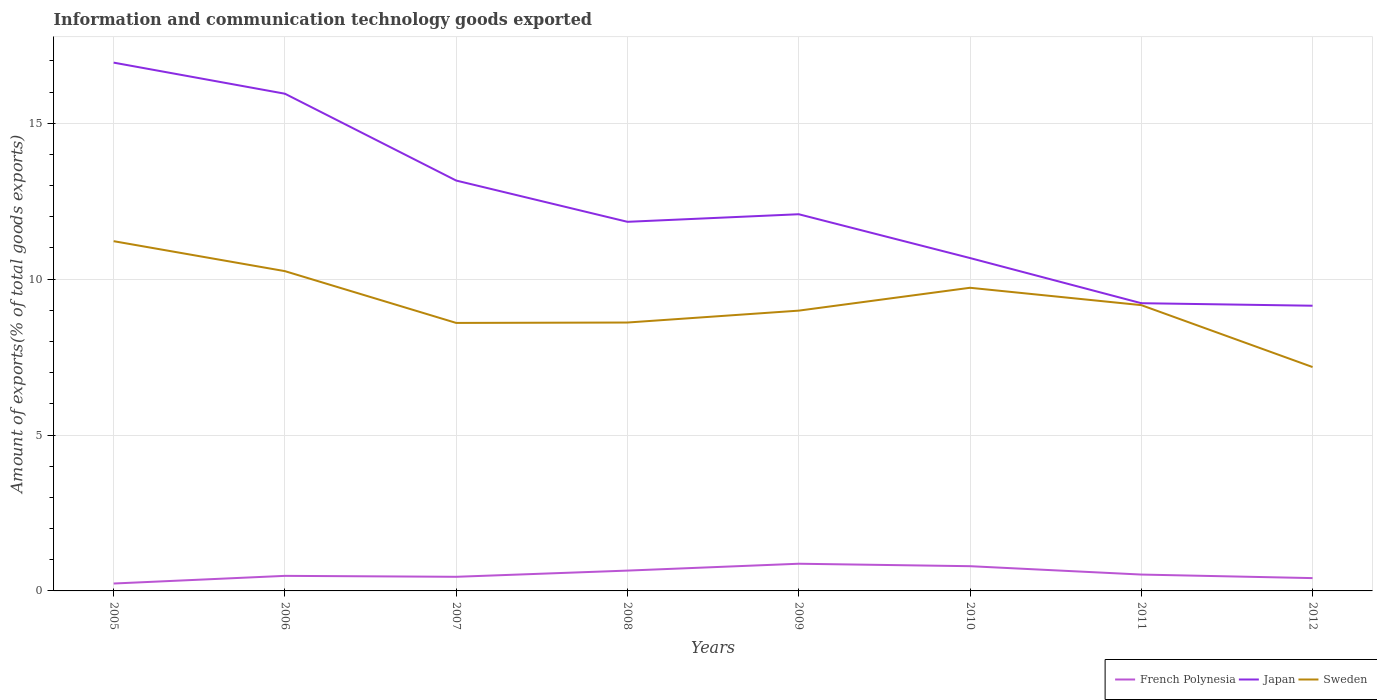How many different coloured lines are there?
Provide a short and direct response. 3. Does the line corresponding to Japan intersect with the line corresponding to Sweden?
Your answer should be compact. No. Across all years, what is the maximum amount of goods exported in French Polynesia?
Keep it short and to the point. 0.24. What is the total amount of goods exported in Sweden in the graph?
Give a very brief answer. 2.62. What is the difference between the highest and the second highest amount of goods exported in Japan?
Provide a short and direct response. 7.8. How many lines are there?
Give a very brief answer. 3. What is the difference between two consecutive major ticks on the Y-axis?
Your answer should be compact. 5. What is the title of the graph?
Provide a succinct answer. Information and communication technology goods exported. What is the label or title of the Y-axis?
Give a very brief answer. Amount of exports(% of total goods exports). What is the Amount of exports(% of total goods exports) of French Polynesia in 2005?
Ensure brevity in your answer.  0.24. What is the Amount of exports(% of total goods exports) in Japan in 2005?
Make the answer very short. 16.95. What is the Amount of exports(% of total goods exports) in Sweden in 2005?
Provide a succinct answer. 11.22. What is the Amount of exports(% of total goods exports) of French Polynesia in 2006?
Your answer should be very brief. 0.48. What is the Amount of exports(% of total goods exports) in Japan in 2006?
Offer a very short reply. 15.95. What is the Amount of exports(% of total goods exports) of Sweden in 2006?
Provide a succinct answer. 10.26. What is the Amount of exports(% of total goods exports) in French Polynesia in 2007?
Offer a very short reply. 0.45. What is the Amount of exports(% of total goods exports) of Japan in 2007?
Make the answer very short. 13.16. What is the Amount of exports(% of total goods exports) in Sweden in 2007?
Your answer should be compact. 8.6. What is the Amount of exports(% of total goods exports) of French Polynesia in 2008?
Provide a short and direct response. 0.65. What is the Amount of exports(% of total goods exports) in Japan in 2008?
Offer a very short reply. 11.84. What is the Amount of exports(% of total goods exports) in Sweden in 2008?
Your answer should be very brief. 8.61. What is the Amount of exports(% of total goods exports) of French Polynesia in 2009?
Offer a very short reply. 0.87. What is the Amount of exports(% of total goods exports) in Japan in 2009?
Keep it short and to the point. 12.08. What is the Amount of exports(% of total goods exports) in Sweden in 2009?
Provide a succinct answer. 8.99. What is the Amount of exports(% of total goods exports) of French Polynesia in 2010?
Keep it short and to the point. 0.79. What is the Amount of exports(% of total goods exports) in Japan in 2010?
Give a very brief answer. 10.68. What is the Amount of exports(% of total goods exports) of Sweden in 2010?
Offer a very short reply. 9.72. What is the Amount of exports(% of total goods exports) of French Polynesia in 2011?
Give a very brief answer. 0.52. What is the Amount of exports(% of total goods exports) in Japan in 2011?
Make the answer very short. 9.23. What is the Amount of exports(% of total goods exports) of Sweden in 2011?
Make the answer very short. 9.17. What is the Amount of exports(% of total goods exports) in French Polynesia in 2012?
Your answer should be compact. 0.41. What is the Amount of exports(% of total goods exports) in Japan in 2012?
Your answer should be very brief. 9.15. What is the Amount of exports(% of total goods exports) in Sweden in 2012?
Give a very brief answer. 7.18. Across all years, what is the maximum Amount of exports(% of total goods exports) in French Polynesia?
Offer a terse response. 0.87. Across all years, what is the maximum Amount of exports(% of total goods exports) of Japan?
Offer a very short reply. 16.95. Across all years, what is the maximum Amount of exports(% of total goods exports) in Sweden?
Provide a short and direct response. 11.22. Across all years, what is the minimum Amount of exports(% of total goods exports) of French Polynesia?
Provide a succinct answer. 0.24. Across all years, what is the minimum Amount of exports(% of total goods exports) in Japan?
Your answer should be very brief. 9.15. Across all years, what is the minimum Amount of exports(% of total goods exports) in Sweden?
Offer a very short reply. 7.18. What is the total Amount of exports(% of total goods exports) in French Polynesia in the graph?
Ensure brevity in your answer.  4.43. What is the total Amount of exports(% of total goods exports) in Japan in the graph?
Offer a terse response. 99.03. What is the total Amount of exports(% of total goods exports) in Sweden in the graph?
Make the answer very short. 73.74. What is the difference between the Amount of exports(% of total goods exports) in French Polynesia in 2005 and that in 2006?
Your answer should be very brief. -0.25. What is the difference between the Amount of exports(% of total goods exports) in Sweden in 2005 and that in 2006?
Your response must be concise. 0.96. What is the difference between the Amount of exports(% of total goods exports) in French Polynesia in 2005 and that in 2007?
Offer a very short reply. -0.22. What is the difference between the Amount of exports(% of total goods exports) of Japan in 2005 and that in 2007?
Provide a short and direct response. 3.78. What is the difference between the Amount of exports(% of total goods exports) in Sweden in 2005 and that in 2007?
Your answer should be compact. 2.62. What is the difference between the Amount of exports(% of total goods exports) in French Polynesia in 2005 and that in 2008?
Make the answer very short. -0.41. What is the difference between the Amount of exports(% of total goods exports) of Japan in 2005 and that in 2008?
Offer a terse response. 5.11. What is the difference between the Amount of exports(% of total goods exports) in Sweden in 2005 and that in 2008?
Provide a succinct answer. 2.61. What is the difference between the Amount of exports(% of total goods exports) in French Polynesia in 2005 and that in 2009?
Make the answer very short. -0.63. What is the difference between the Amount of exports(% of total goods exports) in Japan in 2005 and that in 2009?
Provide a succinct answer. 4.86. What is the difference between the Amount of exports(% of total goods exports) of Sweden in 2005 and that in 2009?
Ensure brevity in your answer.  2.23. What is the difference between the Amount of exports(% of total goods exports) of French Polynesia in 2005 and that in 2010?
Keep it short and to the point. -0.56. What is the difference between the Amount of exports(% of total goods exports) in Japan in 2005 and that in 2010?
Your answer should be compact. 6.27. What is the difference between the Amount of exports(% of total goods exports) in Sweden in 2005 and that in 2010?
Provide a succinct answer. 1.49. What is the difference between the Amount of exports(% of total goods exports) in French Polynesia in 2005 and that in 2011?
Provide a short and direct response. -0.29. What is the difference between the Amount of exports(% of total goods exports) in Japan in 2005 and that in 2011?
Provide a succinct answer. 7.72. What is the difference between the Amount of exports(% of total goods exports) in Sweden in 2005 and that in 2011?
Ensure brevity in your answer.  2.05. What is the difference between the Amount of exports(% of total goods exports) in French Polynesia in 2005 and that in 2012?
Provide a short and direct response. -0.17. What is the difference between the Amount of exports(% of total goods exports) in Japan in 2005 and that in 2012?
Keep it short and to the point. 7.8. What is the difference between the Amount of exports(% of total goods exports) in Sweden in 2005 and that in 2012?
Make the answer very short. 4.04. What is the difference between the Amount of exports(% of total goods exports) of French Polynesia in 2006 and that in 2007?
Give a very brief answer. 0.03. What is the difference between the Amount of exports(% of total goods exports) of Japan in 2006 and that in 2007?
Provide a short and direct response. 2.79. What is the difference between the Amount of exports(% of total goods exports) of Sweden in 2006 and that in 2007?
Ensure brevity in your answer.  1.66. What is the difference between the Amount of exports(% of total goods exports) of French Polynesia in 2006 and that in 2008?
Provide a succinct answer. -0.17. What is the difference between the Amount of exports(% of total goods exports) in Japan in 2006 and that in 2008?
Your answer should be very brief. 4.11. What is the difference between the Amount of exports(% of total goods exports) in Sweden in 2006 and that in 2008?
Keep it short and to the point. 1.65. What is the difference between the Amount of exports(% of total goods exports) in French Polynesia in 2006 and that in 2009?
Offer a terse response. -0.39. What is the difference between the Amount of exports(% of total goods exports) in Japan in 2006 and that in 2009?
Make the answer very short. 3.87. What is the difference between the Amount of exports(% of total goods exports) of Sweden in 2006 and that in 2009?
Make the answer very short. 1.27. What is the difference between the Amount of exports(% of total goods exports) in French Polynesia in 2006 and that in 2010?
Give a very brief answer. -0.31. What is the difference between the Amount of exports(% of total goods exports) in Japan in 2006 and that in 2010?
Your response must be concise. 5.27. What is the difference between the Amount of exports(% of total goods exports) in Sweden in 2006 and that in 2010?
Your answer should be compact. 0.53. What is the difference between the Amount of exports(% of total goods exports) of French Polynesia in 2006 and that in 2011?
Your answer should be compact. -0.04. What is the difference between the Amount of exports(% of total goods exports) in Japan in 2006 and that in 2011?
Give a very brief answer. 6.72. What is the difference between the Amount of exports(% of total goods exports) in Sweden in 2006 and that in 2011?
Offer a very short reply. 1.09. What is the difference between the Amount of exports(% of total goods exports) of French Polynesia in 2006 and that in 2012?
Your answer should be very brief. 0.07. What is the difference between the Amount of exports(% of total goods exports) in Sweden in 2006 and that in 2012?
Provide a short and direct response. 3.08. What is the difference between the Amount of exports(% of total goods exports) of French Polynesia in 2007 and that in 2008?
Your response must be concise. -0.2. What is the difference between the Amount of exports(% of total goods exports) of Japan in 2007 and that in 2008?
Make the answer very short. 1.32. What is the difference between the Amount of exports(% of total goods exports) of Sweden in 2007 and that in 2008?
Give a very brief answer. -0.01. What is the difference between the Amount of exports(% of total goods exports) in French Polynesia in 2007 and that in 2009?
Provide a succinct answer. -0.42. What is the difference between the Amount of exports(% of total goods exports) of Japan in 2007 and that in 2009?
Offer a terse response. 1.08. What is the difference between the Amount of exports(% of total goods exports) of Sweden in 2007 and that in 2009?
Keep it short and to the point. -0.39. What is the difference between the Amount of exports(% of total goods exports) of French Polynesia in 2007 and that in 2010?
Ensure brevity in your answer.  -0.34. What is the difference between the Amount of exports(% of total goods exports) of Japan in 2007 and that in 2010?
Keep it short and to the point. 2.49. What is the difference between the Amount of exports(% of total goods exports) of Sweden in 2007 and that in 2010?
Provide a succinct answer. -1.13. What is the difference between the Amount of exports(% of total goods exports) of French Polynesia in 2007 and that in 2011?
Ensure brevity in your answer.  -0.07. What is the difference between the Amount of exports(% of total goods exports) in Japan in 2007 and that in 2011?
Ensure brevity in your answer.  3.93. What is the difference between the Amount of exports(% of total goods exports) of Sweden in 2007 and that in 2011?
Provide a short and direct response. -0.57. What is the difference between the Amount of exports(% of total goods exports) of French Polynesia in 2007 and that in 2012?
Make the answer very short. 0.04. What is the difference between the Amount of exports(% of total goods exports) in Japan in 2007 and that in 2012?
Offer a terse response. 4.01. What is the difference between the Amount of exports(% of total goods exports) in Sweden in 2007 and that in 2012?
Make the answer very short. 1.42. What is the difference between the Amount of exports(% of total goods exports) of French Polynesia in 2008 and that in 2009?
Your answer should be compact. -0.22. What is the difference between the Amount of exports(% of total goods exports) of Japan in 2008 and that in 2009?
Provide a short and direct response. -0.24. What is the difference between the Amount of exports(% of total goods exports) of Sweden in 2008 and that in 2009?
Offer a very short reply. -0.38. What is the difference between the Amount of exports(% of total goods exports) in French Polynesia in 2008 and that in 2010?
Ensure brevity in your answer.  -0.14. What is the difference between the Amount of exports(% of total goods exports) of Japan in 2008 and that in 2010?
Provide a short and direct response. 1.16. What is the difference between the Amount of exports(% of total goods exports) of Sweden in 2008 and that in 2010?
Make the answer very short. -1.11. What is the difference between the Amount of exports(% of total goods exports) in French Polynesia in 2008 and that in 2011?
Ensure brevity in your answer.  0.13. What is the difference between the Amount of exports(% of total goods exports) of Japan in 2008 and that in 2011?
Offer a terse response. 2.61. What is the difference between the Amount of exports(% of total goods exports) of Sweden in 2008 and that in 2011?
Your answer should be very brief. -0.56. What is the difference between the Amount of exports(% of total goods exports) of French Polynesia in 2008 and that in 2012?
Provide a short and direct response. 0.24. What is the difference between the Amount of exports(% of total goods exports) of Japan in 2008 and that in 2012?
Keep it short and to the point. 2.69. What is the difference between the Amount of exports(% of total goods exports) in Sweden in 2008 and that in 2012?
Provide a short and direct response. 1.43. What is the difference between the Amount of exports(% of total goods exports) in French Polynesia in 2009 and that in 2010?
Give a very brief answer. 0.08. What is the difference between the Amount of exports(% of total goods exports) of Japan in 2009 and that in 2010?
Provide a succinct answer. 1.41. What is the difference between the Amount of exports(% of total goods exports) of Sweden in 2009 and that in 2010?
Make the answer very short. -0.73. What is the difference between the Amount of exports(% of total goods exports) of French Polynesia in 2009 and that in 2011?
Give a very brief answer. 0.35. What is the difference between the Amount of exports(% of total goods exports) in Japan in 2009 and that in 2011?
Make the answer very short. 2.85. What is the difference between the Amount of exports(% of total goods exports) in Sweden in 2009 and that in 2011?
Ensure brevity in your answer.  -0.18. What is the difference between the Amount of exports(% of total goods exports) in French Polynesia in 2009 and that in 2012?
Your response must be concise. 0.46. What is the difference between the Amount of exports(% of total goods exports) in Japan in 2009 and that in 2012?
Your answer should be very brief. 2.93. What is the difference between the Amount of exports(% of total goods exports) in Sweden in 2009 and that in 2012?
Give a very brief answer. 1.81. What is the difference between the Amount of exports(% of total goods exports) of French Polynesia in 2010 and that in 2011?
Make the answer very short. 0.27. What is the difference between the Amount of exports(% of total goods exports) in Japan in 2010 and that in 2011?
Your response must be concise. 1.45. What is the difference between the Amount of exports(% of total goods exports) in Sweden in 2010 and that in 2011?
Provide a succinct answer. 0.56. What is the difference between the Amount of exports(% of total goods exports) in French Polynesia in 2010 and that in 2012?
Offer a terse response. 0.38. What is the difference between the Amount of exports(% of total goods exports) of Japan in 2010 and that in 2012?
Your answer should be very brief. 1.53. What is the difference between the Amount of exports(% of total goods exports) in Sweden in 2010 and that in 2012?
Keep it short and to the point. 2.54. What is the difference between the Amount of exports(% of total goods exports) in French Polynesia in 2011 and that in 2012?
Make the answer very short. 0.11. What is the difference between the Amount of exports(% of total goods exports) of Japan in 2011 and that in 2012?
Keep it short and to the point. 0.08. What is the difference between the Amount of exports(% of total goods exports) of Sweden in 2011 and that in 2012?
Give a very brief answer. 1.99. What is the difference between the Amount of exports(% of total goods exports) in French Polynesia in 2005 and the Amount of exports(% of total goods exports) in Japan in 2006?
Your answer should be very brief. -15.71. What is the difference between the Amount of exports(% of total goods exports) of French Polynesia in 2005 and the Amount of exports(% of total goods exports) of Sweden in 2006?
Provide a succinct answer. -10.02. What is the difference between the Amount of exports(% of total goods exports) of Japan in 2005 and the Amount of exports(% of total goods exports) of Sweden in 2006?
Give a very brief answer. 6.69. What is the difference between the Amount of exports(% of total goods exports) in French Polynesia in 2005 and the Amount of exports(% of total goods exports) in Japan in 2007?
Your response must be concise. -12.92. What is the difference between the Amount of exports(% of total goods exports) in French Polynesia in 2005 and the Amount of exports(% of total goods exports) in Sweden in 2007?
Make the answer very short. -8.36. What is the difference between the Amount of exports(% of total goods exports) of Japan in 2005 and the Amount of exports(% of total goods exports) of Sweden in 2007?
Your answer should be very brief. 8.35. What is the difference between the Amount of exports(% of total goods exports) in French Polynesia in 2005 and the Amount of exports(% of total goods exports) in Japan in 2008?
Offer a very short reply. -11.6. What is the difference between the Amount of exports(% of total goods exports) of French Polynesia in 2005 and the Amount of exports(% of total goods exports) of Sweden in 2008?
Ensure brevity in your answer.  -8.37. What is the difference between the Amount of exports(% of total goods exports) in Japan in 2005 and the Amount of exports(% of total goods exports) in Sweden in 2008?
Your answer should be compact. 8.34. What is the difference between the Amount of exports(% of total goods exports) of French Polynesia in 2005 and the Amount of exports(% of total goods exports) of Japan in 2009?
Provide a short and direct response. -11.84. What is the difference between the Amount of exports(% of total goods exports) of French Polynesia in 2005 and the Amount of exports(% of total goods exports) of Sweden in 2009?
Offer a terse response. -8.75. What is the difference between the Amount of exports(% of total goods exports) of Japan in 2005 and the Amount of exports(% of total goods exports) of Sweden in 2009?
Your answer should be very brief. 7.96. What is the difference between the Amount of exports(% of total goods exports) of French Polynesia in 2005 and the Amount of exports(% of total goods exports) of Japan in 2010?
Provide a short and direct response. -10.44. What is the difference between the Amount of exports(% of total goods exports) of French Polynesia in 2005 and the Amount of exports(% of total goods exports) of Sweden in 2010?
Your answer should be compact. -9.49. What is the difference between the Amount of exports(% of total goods exports) in Japan in 2005 and the Amount of exports(% of total goods exports) in Sweden in 2010?
Ensure brevity in your answer.  7.22. What is the difference between the Amount of exports(% of total goods exports) in French Polynesia in 2005 and the Amount of exports(% of total goods exports) in Japan in 2011?
Keep it short and to the point. -8.99. What is the difference between the Amount of exports(% of total goods exports) of French Polynesia in 2005 and the Amount of exports(% of total goods exports) of Sweden in 2011?
Keep it short and to the point. -8.93. What is the difference between the Amount of exports(% of total goods exports) in Japan in 2005 and the Amount of exports(% of total goods exports) in Sweden in 2011?
Give a very brief answer. 7.78. What is the difference between the Amount of exports(% of total goods exports) in French Polynesia in 2005 and the Amount of exports(% of total goods exports) in Japan in 2012?
Make the answer very short. -8.91. What is the difference between the Amount of exports(% of total goods exports) of French Polynesia in 2005 and the Amount of exports(% of total goods exports) of Sweden in 2012?
Your answer should be compact. -6.94. What is the difference between the Amount of exports(% of total goods exports) in Japan in 2005 and the Amount of exports(% of total goods exports) in Sweden in 2012?
Offer a terse response. 9.76. What is the difference between the Amount of exports(% of total goods exports) in French Polynesia in 2006 and the Amount of exports(% of total goods exports) in Japan in 2007?
Keep it short and to the point. -12.68. What is the difference between the Amount of exports(% of total goods exports) in French Polynesia in 2006 and the Amount of exports(% of total goods exports) in Sweden in 2007?
Offer a terse response. -8.11. What is the difference between the Amount of exports(% of total goods exports) of Japan in 2006 and the Amount of exports(% of total goods exports) of Sweden in 2007?
Give a very brief answer. 7.35. What is the difference between the Amount of exports(% of total goods exports) in French Polynesia in 2006 and the Amount of exports(% of total goods exports) in Japan in 2008?
Give a very brief answer. -11.36. What is the difference between the Amount of exports(% of total goods exports) of French Polynesia in 2006 and the Amount of exports(% of total goods exports) of Sweden in 2008?
Your answer should be very brief. -8.13. What is the difference between the Amount of exports(% of total goods exports) in Japan in 2006 and the Amount of exports(% of total goods exports) in Sweden in 2008?
Provide a short and direct response. 7.34. What is the difference between the Amount of exports(% of total goods exports) in French Polynesia in 2006 and the Amount of exports(% of total goods exports) in Japan in 2009?
Your response must be concise. -11.6. What is the difference between the Amount of exports(% of total goods exports) in French Polynesia in 2006 and the Amount of exports(% of total goods exports) in Sweden in 2009?
Offer a very short reply. -8.51. What is the difference between the Amount of exports(% of total goods exports) of Japan in 2006 and the Amount of exports(% of total goods exports) of Sweden in 2009?
Your response must be concise. 6.96. What is the difference between the Amount of exports(% of total goods exports) in French Polynesia in 2006 and the Amount of exports(% of total goods exports) in Japan in 2010?
Your answer should be compact. -10.19. What is the difference between the Amount of exports(% of total goods exports) in French Polynesia in 2006 and the Amount of exports(% of total goods exports) in Sweden in 2010?
Make the answer very short. -9.24. What is the difference between the Amount of exports(% of total goods exports) in Japan in 2006 and the Amount of exports(% of total goods exports) in Sweden in 2010?
Make the answer very short. 6.22. What is the difference between the Amount of exports(% of total goods exports) of French Polynesia in 2006 and the Amount of exports(% of total goods exports) of Japan in 2011?
Give a very brief answer. -8.75. What is the difference between the Amount of exports(% of total goods exports) in French Polynesia in 2006 and the Amount of exports(% of total goods exports) in Sweden in 2011?
Provide a succinct answer. -8.68. What is the difference between the Amount of exports(% of total goods exports) of Japan in 2006 and the Amount of exports(% of total goods exports) of Sweden in 2011?
Offer a very short reply. 6.78. What is the difference between the Amount of exports(% of total goods exports) of French Polynesia in 2006 and the Amount of exports(% of total goods exports) of Japan in 2012?
Make the answer very short. -8.66. What is the difference between the Amount of exports(% of total goods exports) of French Polynesia in 2006 and the Amount of exports(% of total goods exports) of Sweden in 2012?
Give a very brief answer. -6.7. What is the difference between the Amount of exports(% of total goods exports) in Japan in 2006 and the Amount of exports(% of total goods exports) in Sweden in 2012?
Give a very brief answer. 8.77. What is the difference between the Amount of exports(% of total goods exports) of French Polynesia in 2007 and the Amount of exports(% of total goods exports) of Japan in 2008?
Offer a very short reply. -11.39. What is the difference between the Amount of exports(% of total goods exports) in French Polynesia in 2007 and the Amount of exports(% of total goods exports) in Sweden in 2008?
Your answer should be very brief. -8.16. What is the difference between the Amount of exports(% of total goods exports) of Japan in 2007 and the Amount of exports(% of total goods exports) of Sweden in 2008?
Provide a short and direct response. 4.55. What is the difference between the Amount of exports(% of total goods exports) of French Polynesia in 2007 and the Amount of exports(% of total goods exports) of Japan in 2009?
Ensure brevity in your answer.  -11.63. What is the difference between the Amount of exports(% of total goods exports) in French Polynesia in 2007 and the Amount of exports(% of total goods exports) in Sweden in 2009?
Your response must be concise. -8.54. What is the difference between the Amount of exports(% of total goods exports) in Japan in 2007 and the Amount of exports(% of total goods exports) in Sweden in 2009?
Keep it short and to the point. 4.17. What is the difference between the Amount of exports(% of total goods exports) of French Polynesia in 2007 and the Amount of exports(% of total goods exports) of Japan in 2010?
Give a very brief answer. -10.22. What is the difference between the Amount of exports(% of total goods exports) of French Polynesia in 2007 and the Amount of exports(% of total goods exports) of Sweden in 2010?
Make the answer very short. -9.27. What is the difference between the Amount of exports(% of total goods exports) of Japan in 2007 and the Amount of exports(% of total goods exports) of Sweden in 2010?
Ensure brevity in your answer.  3.44. What is the difference between the Amount of exports(% of total goods exports) in French Polynesia in 2007 and the Amount of exports(% of total goods exports) in Japan in 2011?
Your response must be concise. -8.78. What is the difference between the Amount of exports(% of total goods exports) in French Polynesia in 2007 and the Amount of exports(% of total goods exports) in Sweden in 2011?
Keep it short and to the point. -8.71. What is the difference between the Amount of exports(% of total goods exports) of Japan in 2007 and the Amount of exports(% of total goods exports) of Sweden in 2011?
Offer a terse response. 4. What is the difference between the Amount of exports(% of total goods exports) in French Polynesia in 2007 and the Amount of exports(% of total goods exports) in Japan in 2012?
Make the answer very short. -8.69. What is the difference between the Amount of exports(% of total goods exports) in French Polynesia in 2007 and the Amount of exports(% of total goods exports) in Sweden in 2012?
Ensure brevity in your answer.  -6.73. What is the difference between the Amount of exports(% of total goods exports) of Japan in 2007 and the Amount of exports(% of total goods exports) of Sweden in 2012?
Provide a succinct answer. 5.98. What is the difference between the Amount of exports(% of total goods exports) of French Polynesia in 2008 and the Amount of exports(% of total goods exports) of Japan in 2009?
Provide a succinct answer. -11.43. What is the difference between the Amount of exports(% of total goods exports) in French Polynesia in 2008 and the Amount of exports(% of total goods exports) in Sweden in 2009?
Provide a succinct answer. -8.34. What is the difference between the Amount of exports(% of total goods exports) in Japan in 2008 and the Amount of exports(% of total goods exports) in Sweden in 2009?
Offer a terse response. 2.85. What is the difference between the Amount of exports(% of total goods exports) of French Polynesia in 2008 and the Amount of exports(% of total goods exports) of Japan in 2010?
Your answer should be very brief. -10.02. What is the difference between the Amount of exports(% of total goods exports) in French Polynesia in 2008 and the Amount of exports(% of total goods exports) in Sweden in 2010?
Ensure brevity in your answer.  -9.07. What is the difference between the Amount of exports(% of total goods exports) of Japan in 2008 and the Amount of exports(% of total goods exports) of Sweden in 2010?
Ensure brevity in your answer.  2.12. What is the difference between the Amount of exports(% of total goods exports) of French Polynesia in 2008 and the Amount of exports(% of total goods exports) of Japan in 2011?
Your response must be concise. -8.58. What is the difference between the Amount of exports(% of total goods exports) in French Polynesia in 2008 and the Amount of exports(% of total goods exports) in Sweden in 2011?
Provide a succinct answer. -8.51. What is the difference between the Amount of exports(% of total goods exports) of Japan in 2008 and the Amount of exports(% of total goods exports) of Sweden in 2011?
Your answer should be very brief. 2.67. What is the difference between the Amount of exports(% of total goods exports) in French Polynesia in 2008 and the Amount of exports(% of total goods exports) in Japan in 2012?
Make the answer very short. -8.5. What is the difference between the Amount of exports(% of total goods exports) in French Polynesia in 2008 and the Amount of exports(% of total goods exports) in Sweden in 2012?
Provide a succinct answer. -6.53. What is the difference between the Amount of exports(% of total goods exports) of Japan in 2008 and the Amount of exports(% of total goods exports) of Sweden in 2012?
Offer a terse response. 4.66. What is the difference between the Amount of exports(% of total goods exports) in French Polynesia in 2009 and the Amount of exports(% of total goods exports) in Japan in 2010?
Your response must be concise. -9.8. What is the difference between the Amount of exports(% of total goods exports) in French Polynesia in 2009 and the Amount of exports(% of total goods exports) in Sweden in 2010?
Keep it short and to the point. -8.85. What is the difference between the Amount of exports(% of total goods exports) in Japan in 2009 and the Amount of exports(% of total goods exports) in Sweden in 2010?
Provide a short and direct response. 2.36. What is the difference between the Amount of exports(% of total goods exports) of French Polynesia in 2009 and the Amount of exports(% of total goods exports) of Japan in 2011?
Provide a short and direct response. -8.36. What is the difference between the Amount of exports(% of total goods exports) in French Polynesia in 2009 and the Amount of exports(% of total goods exports) in Sweden in 2011?
Your answer should be compact. -8.29. What is the difference between the Amount of exports(% of total goods exports) of Japan in 2009 and the Amount of exports(% of total goods exports) of Sweden in 2011?
Give a very brief answer. 2.92. What is the difference between the Amount of exports(% of total goods exports) in French Polynesia in 2009 and the Amount of exports(% of total goods exports) in Japan in 2012?
Your answer should be compact. -8.28. What is the difference between the Amount of exports(% of total goods exports) of French Polynesia in 2009 and the Amount of exports(% of total goods exports) of Sweden in 2012?
Offer a terse response. -6.31. What is the difference between the Amount of exports(% of total goods exports) in Japan in 2009 and the Amount of exports(% of total goods exports) in Sweden in 2012?
Your response must be concise. 4.9. What is the difference between the Amount of exports(% of total goods exports) in French Polynesia in 2010 and the Amount of exports(% of total goods exports) in Japan in 2011?
Offer a terse response. -8.43. What is the difference between the Amount of exports(% of total goods exports) in French Polynesia in 2010 and the Amount of exports(% of total goods exports) in Sweden in 2011?
Make the answer very short. -8.37. What is the difference between the Amount of exports(% of total goods exports) of Japan in 2010 and the Amount of exports(% of total goods exports) of Sweden in 2011?
Provide a short and direct response. 1.51. What is the difference between the Amount of exports(% of total goods exports) of French Polynesia in 2010 and the Amount of exports(% of total goods exports) of Japan in 2012?
Your answer should be compact. -8.35. What is the difference between the Amount of exports(% of total goods exports) of French Polynesia in 2010 and the Amount of exports(% of total goods exports) of Sweden in 2012?
Give a very brief answer. -6.39. What is the difference between the Amount of exports(% of total goods exports) in Japan in 2010 and the Amount of exports(% of total goods exports) in Sweden in 2012?
Your response must be concise. 3.5. What is the difference between the Amount of exports(% of total goods exports) of French Polynesia in 2011 and the Amount of exports(% of total goods exports) of Japan in 2012?
Your answer should be compact. -8.62. What is the difference between the Amount of exports(% of total goods exports) in French Polynesia in 2011 and the Amount of exports(% of total goods exports) in Sweden in 2012?
Make the answer very short. -6.66. What is the difference between the Amount of exports(% of total goods exports) of Japan in 2011 and the Amount of exports(% of total goods exports) of Sweden in 2012?
Offer a terse response. 2.05. What is the average Amount of exports(% of total goods exports) in French Polynesia per year?
Offer a very short reply. 0.55. What is the average Amount of exports(% of total goods exports) in Japan per year?
Your response must be concise. 12.38. What is the average Amount of exports(% of total goods exports) of Sweden per year?
Your response must be concise. 9.22. In the year 2005, what is the difference between the Amount of exports(% of total goods exports) in French Polynesia and Amount of exports(% of total goods exports) in Japan?
Give a very brief answer. -16.71. In the year 2005, what is the difference between the Amount of exports(% of total goods exports) of French Polynesia and Amount of exports(% of total goods exports) of Sweden?
Ensure brevity in your answer.  -10.98. In the year 2005, what is the difference between the Amount of exports(% of total goods exports) of Japan and Amount of exports(% of total goods exports) of Sweden?
Keep it short and to the point. 5.73. In the year 2006, what is the difference between the Amount of exports(% of total goods exports) in French Polynesia and Amount of exports(% of total goods exports) in Japan?
Your response must be concise. -15.46. In the year 2006, what is the difference between the Amount of exports(% of total goods exports) in French Polynesia and Amount of exports(% of total goods exports) in Sweden?
Keep it short and to the point. -9.77. In the year 2006, what is the difference between the Amount of exports(% of total goods exports) of Japan and Amount of exports(% of total goods exports) of Sweden?
Give a very brief answer. 5.69. In the year 2007, what is the difference between the Amount of exports(% of total goods exports) of French Polynesia and Amount of exports(% of total goods exports) of Japan?
Make the answer very short. -12.71. In the year 2007, what is the difference between the Amount of exports(% of total goods exports) of French Polynesia and Amount of exports(% of total goods exports) of Sweden?
Your response must be concise. -8.14. In the year 2007, what is the difference between the Amount of exports(% of total goods exports) in Japan and Amount of exports(% of total goods exports) in Sweden?
Your answer should be compact. 4.57. In the year 2008, what is the difference between the Amount of exports(% of total goods exports) of French Polynesia and Amount of exports(% of total goods exports) of Japan?
Provide a short and direct response. -11.19. In the year 2008, what is the difference between the Amount of exports(% of total goods exports) of French Polynesia and Amount of exports(% of total goods exports) of Sweden?
Offer a terse response. -7.96. In the year 2008, what is the difference between the Amount of exports(% of total goods exports) in Japan and Amount of exports(% of total goods exports) in Sweden?
Keep it short and to the point. 3.23. In the year 2009, what is the difference between the Amount of exports(% of total goods exports) in French Polynesia and Amount of exports(% of total goods exports) in Japan?
Your answer should be compact. -11.21. In the year 2009, what is the difference between the Amount of exports(% of total goods exports) in French Polynesia and Amount of exports(% of total goods exports) in Sweden?
Your answer should be compact. -8.12. In the year 2009, what is the difference between the Amount of exports(% of total goods exports) of Japan and Amount of exports(% of total goods exports) of Sweden?
Your response must be concise. 3.09. In the year 2010, what is the difference between the Amount of exports(% of total goods exports) in French Polynesia and Amount of exports(% of total goods exports) in Japan?
Keep it short and to the point. -9.88. In the year 2010, what is the difference between the Amount of exports(% of total goods exports) in French Polynesia and Amount of exports(% of total goods exports) in Sweden?
Offer a terse response. -8.93. In the year 2010, what is the difference between the Amount of exports(% of total goods exports) in Japan and Amount of exports(% of total goods exports) in Sweden?
Your response must be concise. 0.95. In the year 2011, what is the difference between the Amount of exports(% of total goods exports) of French Polynesia and Amount of exports(% of total goods exports) of Japan?
Offer a terse response. -8.7. In the year 2011, what is the difference between the Amount of exports(% of total goods exports) of French Polynesia and Amount of exports(% of total goods exports) of Sweden?
Keep it short and to the point. -8.64. In the year 2011, what is the difference between the Amount of exports(% of total goods exports) in Japan and Amount of exports(% of total goods exports) in Sweden?
Make the answer very short. 0.06. In the year 2012, what is the difference between the Amount of exports(% of total goods exports) of French Polynesia and Amount of exports(% of total goods exports) of Japan?
Your answer should be very brief. -8.74. In the year 2012, what is the difference between the Amount of exports(% of total goods exports) in French Polynesia and Amount of exports(% of total goods exports) in Sweden?
Offer a very short reply. -6.77. In the year 2012, what is the difference between the Amount of exports(% of total goods exports) in Japan and Amount of exports(% of total goods exports) in Sweden?
Keep it short and to the point. 1.97. What is the ratio of the Amount of exports(% of total goods exports) of French Polynesia in 2005 to that in 2006?
Offer a terse response. 0.49. What is the ratio of the Amount of exports(% of total goods exports) in Sweden in 2005 to that in 2006?
Ensure brevity in your answer.  1.09. What is the ratio of the Amount of exports(% of total goods exports) of French Polynesia in 2005 to that in 2007?
Make the answer very short. 0.52. What is the ratio of the Amount of exports(% of total goods exports) of Japan in 2005 to that in 2007?
Your response must be concise. 1.29. What is the ratio of the Amount of exports(% of total goods exports) of Sweden in 2005 to that in 2007?
Your response must be concise. 1.3. What is the ratio of the Amount of exports(% of total goods exports) of French Polynesia in 2005 to that in 2008?
Make the answer very short. 0.36. What is the ratio of the Amount of exports(% of total goods exports) in Japan in 2005 to that in 2008?
Offer a very short reply. 1.43. What is the ratio of the Amount of exports(% of total goods exports) of Sweden in 2005 to that in 2008?
Provide a short and direct response. 1.3. What is the ratio of the Amount of exports(% of total goods exports) of French Polynesia in 2005 to that in 2009?
Make the answer very short. 0.27. What is the ratio of the Amount of exports(% of total goods exports) of Japan in 2005 to that in 2009?
Make the answer very short. 1.4. What is the ratio of the Amount of exports(% of total goods exports) in Sweden in 2005 to that in 2009?
Provide a short and direct response. 1.25. What is the ratio of the Amount of exports(% of total goods exports) of French Polynesia in 2005 to that in 2010?
Your answer should be compact. 0.3. What is the ratio of the Amount of exports(% of total goods exports) in Japan in 2005 to that in 2010?
Give a very brief answer. 1.59. What is the ratio of the Amount of exports(% of total goods exports) in Sweden in 2005 to that in 2010?
Keep it short and to the point. 1.15. What is the ratio of the Amount of exports(% of total goods exports) of French Polynesia in 2005 to that in 2011?
Make the answer very short. 0.45. What is the ratio of the Amount of exports(% of total goods exports) of Japan in 2005 to that in 2011?
Offer a terse response. 1.84. What is the ratio of the Amount of exports(% of total goods exports) in Sweden in 2005 to that in 2011?
Give a very brief answer. 1.22. What is the ratio of the Amount of exports(% of total goods exports) of French Polynesia in 2005 to that in 2012?
Offer a terse response. 0.58. What is the ratio of the Amount of exports(% of total goods exports) of Japan in 2005 to that in 2012?
Keep it short and to the point. 1.85. What is the ratio of the Amount of exports(% of total goods exports) of Sweden in 2005 to that in 2012?
Offer a very short reply. 1.56. What is the ratio of the Amount of exports(% of total goods exports) in French Polynesia in 2006 to that in 2007?
Offer a very short reply. 1.07. What is the ratio of the Amount of exports(% of total goods exports) of Japan in 2006 to that in 2007?
Ensure brevity in your answer.  1.21. What is the ratio of the Amount of exports(% of total goods exports) of Sweden in 2006 to that in 2007?
Give a very brief answer. 1.19. What is the ratio of the Amount of exports(% of total goods exports) of French Polynesia in 2006 to that in 2008?
Ensure brevity in your answer.  0.74. What is the ratio of the Amount of exports(% of total goods exports) in Japan in 2006 to that in 2008?
Give a very brief answer. 1.35. What is the ratio of the Amount of exports(% of total goods exports) in Sweden in 2006 to that in 2008?
Keep it short and to the point. 1.19. What is the ratio of the Amount of exports(% of total goods exports) in French Polynesia in 2006 to that in 2009?
Make the answer very short. 0.55. What is the ratio of the Amount of exports(% of total goods exports) of Japan in 2006 to that in 2009?
Ensure brevity in your answer.  1.32. What is the ratio of the Amount of exports(% of total goods exports) in Sweden in 2006 to that in 2009?
Ensure brevity in your answer.  1.14. What is the ratio of the Amount of exports(% of total goods exports) in French Polynesia in 2006 to that in 2010?
Offer a terse response. 0.61. What is the ratio of the Amount of exports(% of total goods exports) in Japan in 2006 to that in 2010?
Provide a short and direct response. 1.49. What is the ratio of the Amount of exports(% of total goods exports) of Sweden in 2006 to that in 2010?
Your answer should be very brief. 1.05. What is the ratio of the Amount of exports(% of total goods exports) in French Polynesia in 2006 to that in 2011?
Offer a terse response. 0.92. What is the ratio of the Amount of exports(% of total goods exports) of Japan in 2006 to that in 2011?
Offer a very short reply. 1.73. What is the ratio of the Amount of exports(% of total goods exports) of Sweden in 2006 to that in 2011?
Offer a terse response. 1.12. What is the ratio of the Amount of exports(% of total goods exports) of French Polynesia in 2006 to that in 2012?
Offer a very short reply. 1.18. What is the ratio of the Amount of exports(% of total goods exports) of Japan in 2006 to that in 2012?
Provide a short and direct response. 1.74. What is the ratio of the Amount of exports(% of total goods exports) in Sweden in 2006 to that in 2012?
Provide a succinct answer. 1.43. What is the ratio of the Amount of exports(% of total goods exports) in French Polynesia in 2007 to that in 2008?
Give a very brief answer. 0.69. What is the ratio of the Amount of exports(% of total goods exports) in Japan in 2007 to that in 2008?
Your answer should be very brief. 1.11. What is the ratio of the Amount of exports(% of total goods exports) of French Polynesia in 2007 to that in 2009?
Make the answer very short. 0.52. What is the ratio of the Amount of exports(% of total goods exports) in Japan in 2007 to that in 2009?
Ensure brevity in your answer.  1.09. What is the ratio of the Amount of exports(% of total goods exports) of Sweden in 2007 to that in 2009?
Ensure brevity in your answer.  0.96. What is the ratio of the Amount of exports(% of total goods exports) in French Polynesia in 2007 to that in 2010?
Your answer should be compact. 0.57. What is the ratio of the Amount of exports(% of total goods exports) of Japan in 2007 to that in 2010?
Your response must be concise. 1.23. What is the ratio of the Amount of exports(% of total goods exports) in Sweden in 2007 to that in 2010?
Your answer should be compact. 0.88. What is the ratio of the Amount of exports(% of total goods exports) in French Polynesia in 2007 to that in 2011?
Keep it short and to the point. 0.86. What is the ratio of the Amount of exports(% of total goods exports) of Japan in 2007 to that in 2011?
Provide a succinct answer. 1.43. What is the ratio of the Amount of exports(% of total goods exports) of Sweden in 2007 to that in 2011?
Make the answer very short. 0.94. What is the ratio of the Amount of exports(% of total goods exports) in French Polynesia in 2007 to that in 2012?
Give a very brief answer. 1.1. What is the ratio of the Amount of exports(% of total goods exports) of Japan in 2007 to that in 2012?
Your answer should be very brief. 1.44. What is the ratio of the Amount of exports(% of total goods exports) of Sweden in 2007 to that in 2012?
Your answer should be compact. 1.2. What is the ratio of the Amount of exports(% of total goods exports) of French Polynesia in 2008 to that in 2009?
Your response must be concise. 0.75. What is the ratio of the Amount of exports(% of total goods exports) of Japan in 2008 to that in 2009?
Offer a terse response. 0.98. What is the ratio of the Amount of exports(% of total goods exports) of Sweden in 2008 to that in 2009?
Make the answer very short. 0.96. What is the ratio of the Amount of exports(% of total goods exports) of French Polynesia in 2008 to that in 2010?
Give a very brief answer. 0.82. What is the ratio of the Amount of exports(% of total goods exports) of Japan in 2008 to that in 2010?
Make the answer very short. 1.11. What is the ratio of the Amount of exports(% of total goods exports) in Sweden in 2008 to that in 2010?
Keep it short and to the point. 0.89. What is the ratio of the Amount of exports(% of total goods exports) in French Polynesia in 2008 to that in 2011?
Your answer should be very brief. 1.24. What is the ratio of the Amount of exports(% of total goods exports) in Japan in 2008 to that in 2011?
Your response must be concise. 1.28. What is the ratio of the Amount of exports(% of total goods exports) of Sweden in 2008 to that in 2011?
Your response must be concise. 0.94. What is the ratio of the Amount of exports(% of total goods exports) of French Polynesia in 2008 to that in 2012?
Offer a terse response. 1.59. What is the ratio of the Amount of exports(% of total goods exports) in Japan in 2008 to that in 2012?
Provide a succinct answer. 1.29. What is the ratio of the Amount of exports(% of total goods exports) in Sweden in 2008 to that in 2012?
Offer a terse response. 1.2. What is the ratio of the Amount of exports(% of total goods exports) of French Polynesia in 2009 to that in 2010?
Your answer should be compact. 1.1. What is the ratio of the Amount of exports(% of total goods exports) of Japan in 2009 to that in 2010?
Offer a terse response. 1.13. What is the ratio of the Amount of exports(% of total goods exports) in Sweden in 2009 to that in 2010?
Ensure brevity in your answer.  0.92. What is the ratio of the Amount of exports(% of total goods exports) in French Polynesia in 2009 to that in 2011?
Ensure brevity in your answer.  1.66. What is the ratio of the Amount of exports(% of total goods exports) in Japan in 2009 to that in 2011?
Your response must be concise. 1.31. What is the ratio of the Amount of exports(% of total goods exports) of Sweden in 2009 to that in 2011?
Keep it short and to the point. 0.98. What is the ratio of the Amount of exports(% of total goods exports) in French Polynesia in 2009 to that in 2012?
Ensure brevity in your answer.  2.12. What is the ratio of the Amount of exports(% of total goods exports) of Japan in 2009 to that in 2012?
Provide a succinct answer. 1.32. What is the ratio of the Amount of exports(% of total goods exports) of Sweden in 2009 to that in 2012?
Provide a succinct answer. 1.25. What is the ratio of the Amount of exports(% of total goods exports) in French Polynesia in 2010 to that in 2011?
Provide a short and direct response. 1.51. What is the ratio of the Amount of exports(% of total goods exports) of Japan in 2010 to that in 2011?
Your answer should be very brief. 1.16. What is the ratio of the Amount of exports(% of total goods exports) in Sweden in 2010 to that in 2011?
Your answer should be very brief. 1.06. What is the ratio of the Amount of exports(% of total goods exports) in French Polynesia in 2010 to that in 2012?
Offer a very short reply. 1.93. What is the ratio of the Amount of exports(% of total goods exports) of Japan in 2010 to that in 2012?
Offer a very short reply. 1.17. What is the ratio of the Amount of exports(% of total goods exports) in Sweden in 2010 to that in 2012?
Your response must be concise. 1.35. What is the ratio of the Amount of exports(% of total goods exports) of French Polynesia in 2011 to that in 2012?
Ensure brevity in your answer.  1.28. What is the ratio of the Amount of exports(% of total goods exports) in Japan in 2011 to that in 2012?
Provide a succinct answer. 1.01. What is the ratio of the Amount of exports(% of total goods exports) of Sweden in 2011 to that in 2012?
Keep it short and to the point. 1.28. What is the difference between the highest and the second highest Amount of exports(% of total goods exports) of French Polynesia?
Your answer should be very brief. 0.08. What is the difference between the highest and the second highest Amount of exports(% of total goods exports) in Japan?
Ensure brevity in your answer.  1. What is the difference between the highest and the second highest Amount of exports(% of total goods exports) in Sweden?
Make the answer very short. 0.96. What is the difference between the highest and the lowest Amount of exports(% of total goods exports) of French Polynesia?
Provide a short and direct response. 0.63. What is the difference between the highest and the lowest Amount of exports(% of total goods exports) of Japan?
Keep it short and to the point. 7.8. What is the difference between the highest and the lowest Amount of exports(% of total goods exports) in Sweden?
Give a very brief answer. 4.04. 